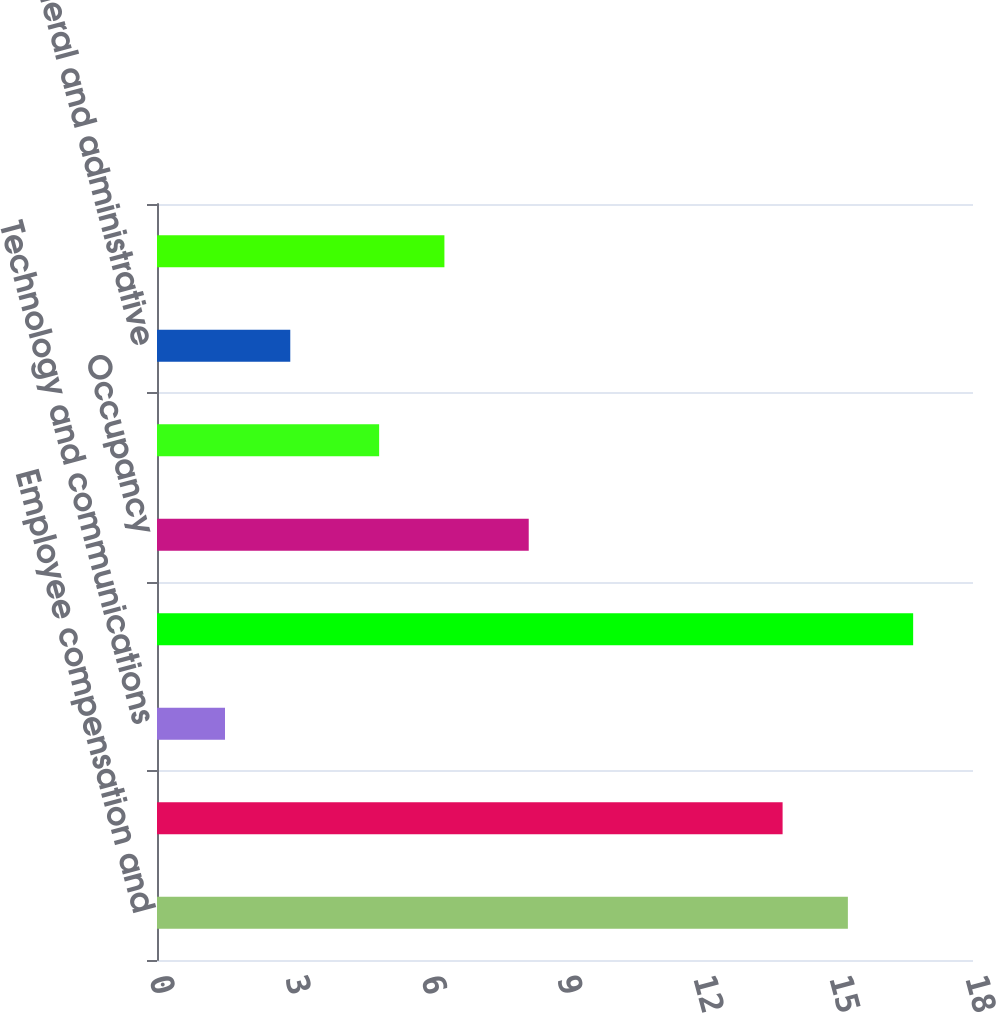<chart> <loc_0><loc_0><loc_500><loc_500><bar_chart><fcel>Employee compensation and<fcel>Depreciation and amortization<fcel>Technology and communications<fcel>Professional and consulting<fcel>Occupancy<fcel>Marketing and advertising<fcel>General and administrative<fcel>Total expenses<nl><fcel>15.24<fcel>13.8<fcel>1.5<fcel>16.68<fcel>8.2<fcel>4.9<fcel>2.94<fcel>6.34<nl></chart> 